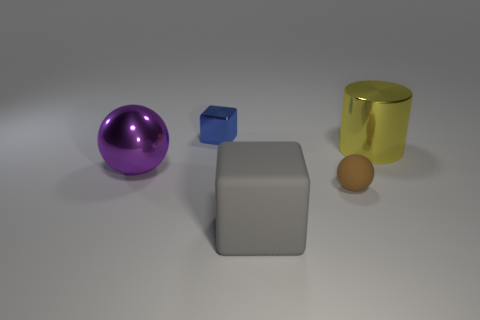Are there any gray cubes of the same size as the gray rubber object? No, there are not. The gray cube in the image is smaller than the gray rubber object. 